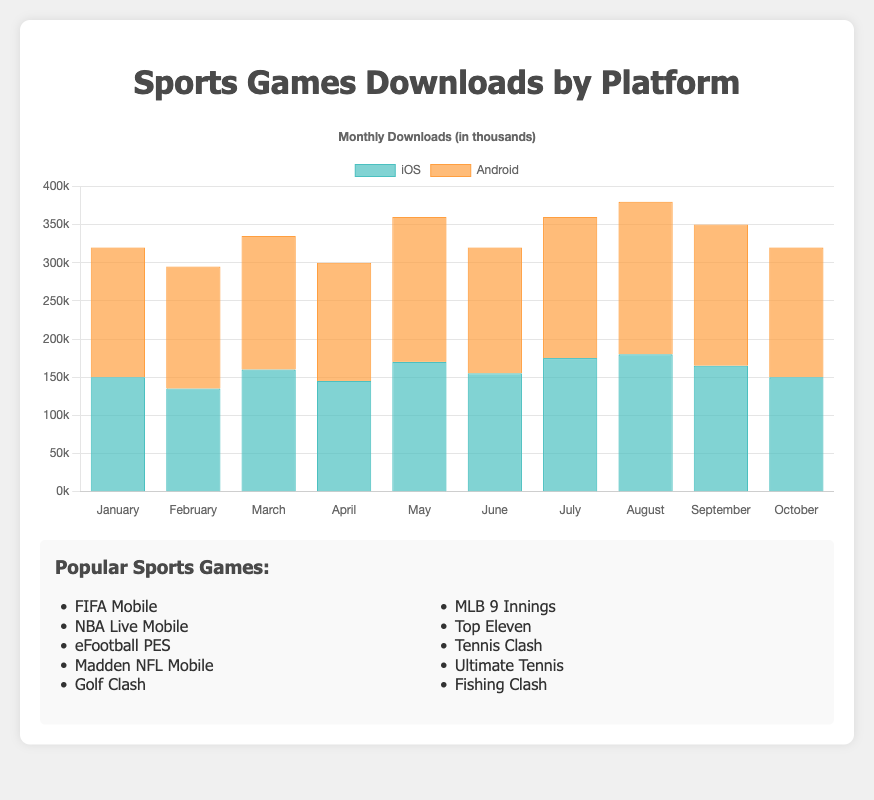Which month had the highest total downloads across both iOS and Android? Adding the downloads for both iOS and Android for each month, August has the most with iOS (180,000) and Android (200,000). The total is 380,000.
Answer: August Which platform had more downloads in May? Comparing the downloads in May: iOS had 170,000 and Android had 190,000. Thus, Android had more.
Answer: Android What is the average number of downloads per month for Android in the first quarter (January, February, March)? Summing the downloads for January (170,000), February (160,000), and March (175,000), we get 505,000. Dividing by 3, the average is 168,333.
Answer: 168,333 By how much did the downloads increase or decrease from February to March for iOS? iOS downloads in February were 135,000 and in March were 160,000. The increase is 160,000 - 135,000 = 25,000.
Answer: 25,000 In which month did iOS downloads peak, and what was the number of downloads? Looking at the iOS data, the peaks are in July and August, both with 180,000 downloads.
Answer: August (or July), 180,000 Which month saw the smallest difference in downloads between iOS and Android? Calculating the differences for each month: January (20,000), February (25,000), March (15,000), April (10,000), May (20,000), June (10,000), July (10,000), August (20,000), September (20,000), October (20,000). April, June, and July have the smallest difference of 10,000.
Answer: April (or June, or July) Which device type had more downloads in the month of April, and by how much? In April, iOS had 145,000 downloads while Android had 155,000 downloads. Android had 10,000 more downloads than iOS.
Answer: Android, 10,000 What is the trend of iOS downloads from January to October? Observing the monthly downloads for iOS: January (150,000), February (135,000), March (160,000), April (145,000), May (170,000), June (155,000), July (175,000), August (180,000), September (165,000), October (150,000). It shows fluctuation with peaks in July and August and a general upward trend until August, followed by a decline.
Answer: Fluctuating with peaks in July and August How many times did Android downloads exceed 180,000 in a month, and which months were they? Checking the data for Android: the months with downloads over 180,000 are May (190,000), July (185,000), August (200,000), and September (185,000). This happened 4 times.
Answer: 4 times, May, July, August, September 